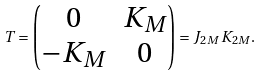<formula> <loc_0><loc_0><loc_500><loc_500>T = \begin{pmatrix} 0 & K _ { M } \\ - K _ { M } & 0 \end{pmatrix} = J _ { 2 M } \, K _ { 2 M } .</formula> 